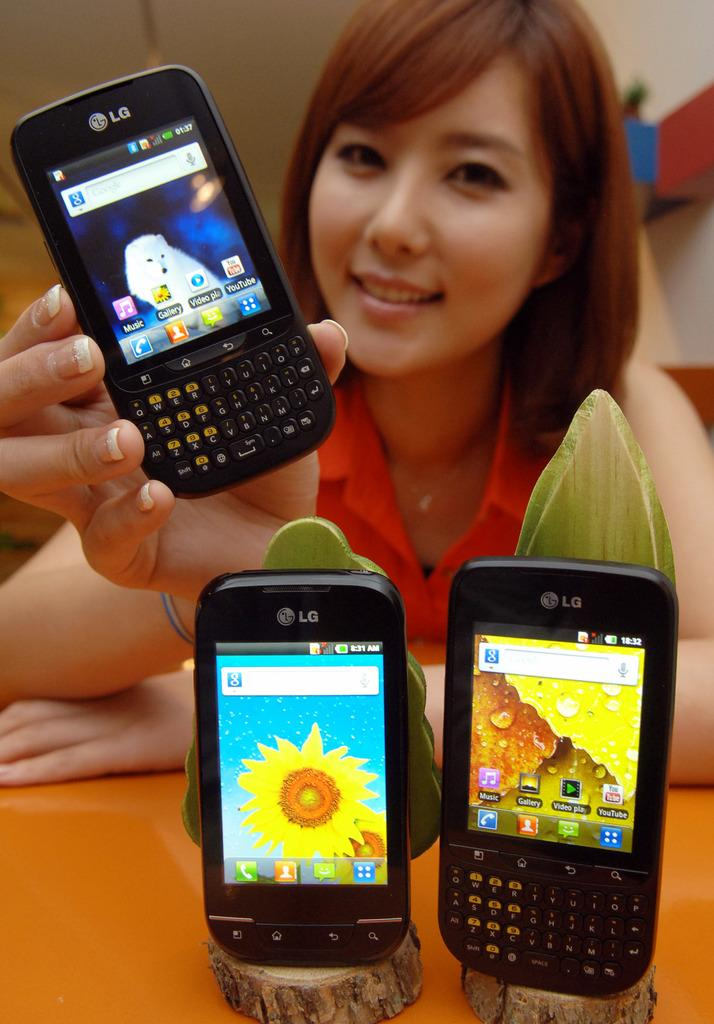<image>
Relay a brief, clear account of the picture shown. The brand of phone she is holding is an LG 